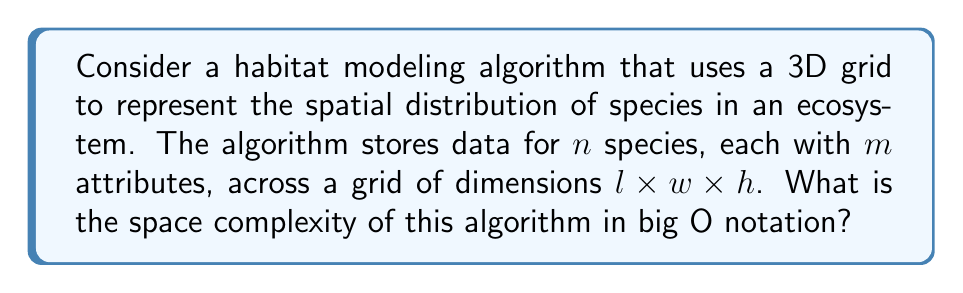What is the answer to this math problem? To determine the space complexity of this habitat modeling algorithm, we need to analyze the amount of memory required to store the data:

1. Grid representation:
   The 3D grid has dimensions $l \times w \times h$, which means it has $l \cdot w \cdot h$ cells in total.

2. Species data:
   For each cell in the grid, we need to store data for $n$ species.

3. Attribute data:
   Each species has $m$ attributes that need to be stored.

Therefore, the total amount of memory required can be calculated as:

$$ \text{Total Memory} = l \cdot w \cdot h \cdot n \cdot m $$

In big O notation, we express this as:

$$ O(l \cdot w \cdot h \cdot n \cdot m) $$

Since all of these variables ($l$, $w$, $h$, $n$, and $m$) are independent inputs to the algorithm, we cannot simplify this expression further without making additional assumptions about their relationships.

This space complexity reflects the need to store detailed information about multiple species and their attributes across a three-dimensional representation of the habitat, which is crucial for accurate biodiversity and ecological balance studies.
Answer: $O(l \cdot w \cdot h \cdot n \cdot m)$ 